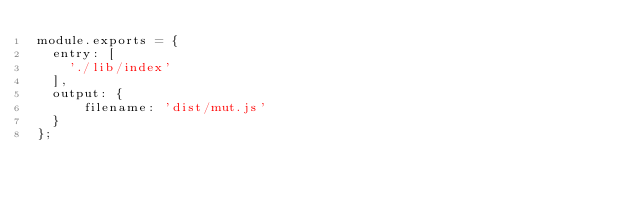<code> <loc_0><loc_0><loc_500><loc_500><_JavaScript_>module.exports = {
  entry: [
    './lib/index'
  ],
  output: {
      filename: 'dist/mut.js'
  }
};
</code> 